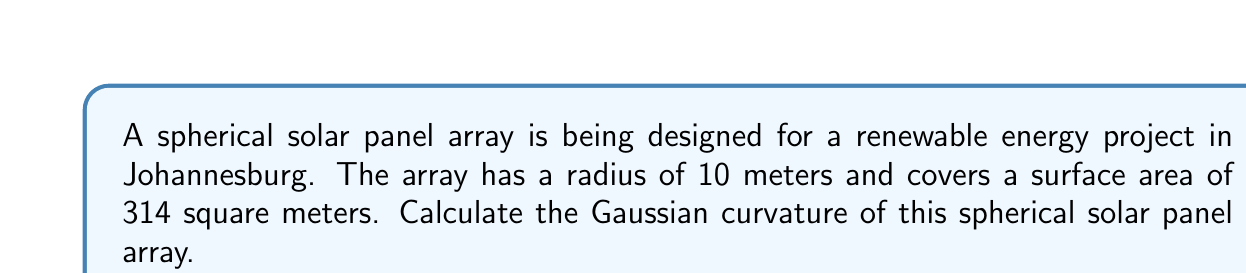Give your solution to this math problem. To calculate the Gaussian curvature of a spherical solar panel array, we'll follow these steps:

1. Recall that for a sphere, the Gaussian curvature $K$ is constant and given by:

   $$K = \frac{1}{R^2}$$

   where $R$ is the radius of the sphere.

2. We are given that the radius of the spherical array is 10 meters. Let's substitute this into our equation:

   $$K = \frac{1}{(10 \text{ m})^2}$$

3. Simplify:

   $$K = \frac{1}{100 \text{ m}^2}$$

4. Convert to standard units (per square meter):

   $$K = 0.01 \text{ m}^{-2}$$

Note: The surface area given (314 square meters) is consistent with our calculation, as the surface area of a sphere is given by $4\pi R^2 = 4\pi(10 \text{ m})^2 \approx 1256 \text{ m}^2$, and 314 square meters is approximately a quarter of this, which could represent the usable area for solar panels.

[asy]
import geometry;

size(200);
draw(circle((0,0),5));
draw((-5,0)--(5,0),dashed);
draw((0,-5)--(0,5),dashed);
label("R",(2.5,2.5),NE);
dot((0,0));
[/asy]
Answer: $0.01 \text{ m}^{-2}$ 